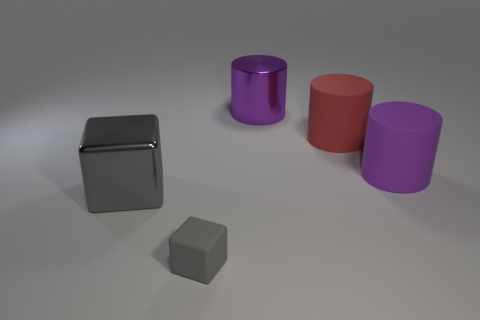Subtract all big rubber cylinders. How many cylinders are left? 1 Subtract all brown blocks. How many purple cylinders are left? 2 Add 2 tiny gray blocks. How many objects exist? 7 Subtract all purple cylinders. How many cylinders are left? 1 Subtract 2 cylinders. How many cylinders are left? 1 Subtract all cubes. How many objects are left? 3 Subtract 0 brown cylinders. How many objects are left? 5 Subtract all green cylinders. Subtract all red blocks. How many cylinders are left? 3 Subtract all purple matte cylinders. Subtract all gray objects. How many objects are left? 2 Add 3 large purple metal cylinders. How many large purple metal cylinders are left? 4 